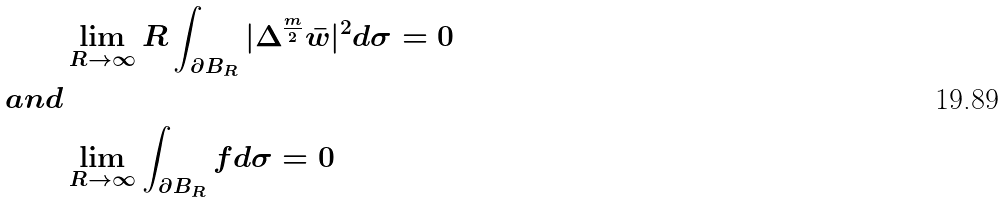Convert formula to latex. <formula><loc_0><loc_0><loc_500><loc_500>& \lim _ { R \to \infty } R \int _ { \partial B _ { R } } | \Delta ^ { \frac { m } { 2 } } \bar { w } | ^ { 2 } d \sigma = 0 \\ a n d & \\ & \lim _ { R \to \infty } \int _ { \partial B _ { R } } f d \sigma = 0</formula> 